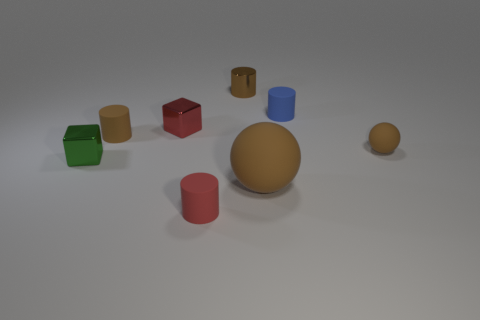Is there a small gray thing made of the same material as the tiny blue cylinder? Although I cannot assess the materials with certainty from an image, there does not appear to be a small gray object resembling the tiny blue cylinder in either shape or color. 